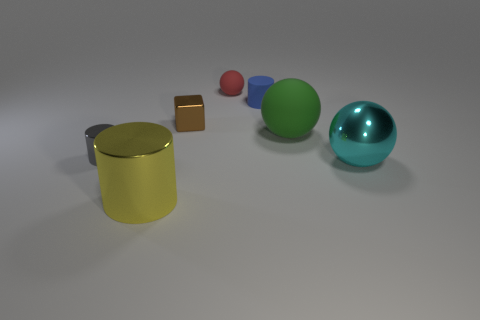Is there anything else that is the same color as the small metal block?
Ensure brevity in your answer.  No. How big is the rubber sphere that is in front of the red rubber thing?
Give a very brief answer. Large. There is a ball right of the rubber sphere in front of the tiny rubber object in front of the red thing; what is its size?
Make the answer very short. Large. What is the color of the cylinder to the left of the cylinder that is in front of the cyan object?
Provide a succinct answer. Gray. What is the material of the yellow object that is the same shape as the small gray thing?
Provide a succinct answer. Metal. Are there any other things that are made of the same material as the red sphere?
Keep it short and to the point. Yes. There is a yellow metallic cylinder; are there any yellow things to the right of it?
Provide a short and direct response. No. What number of tiny green shiny spheres are there?
Provide a short and direct response. 0. How many small cylinders are in front of the tiny cylinder to the right of the tiny red matte object?
Your answer should be very brief. 1. There is a large cylinder; is its color the same as the cylinder behind the tiny gray shiny cylinder?
Ensure brevity in your answer.  No. 